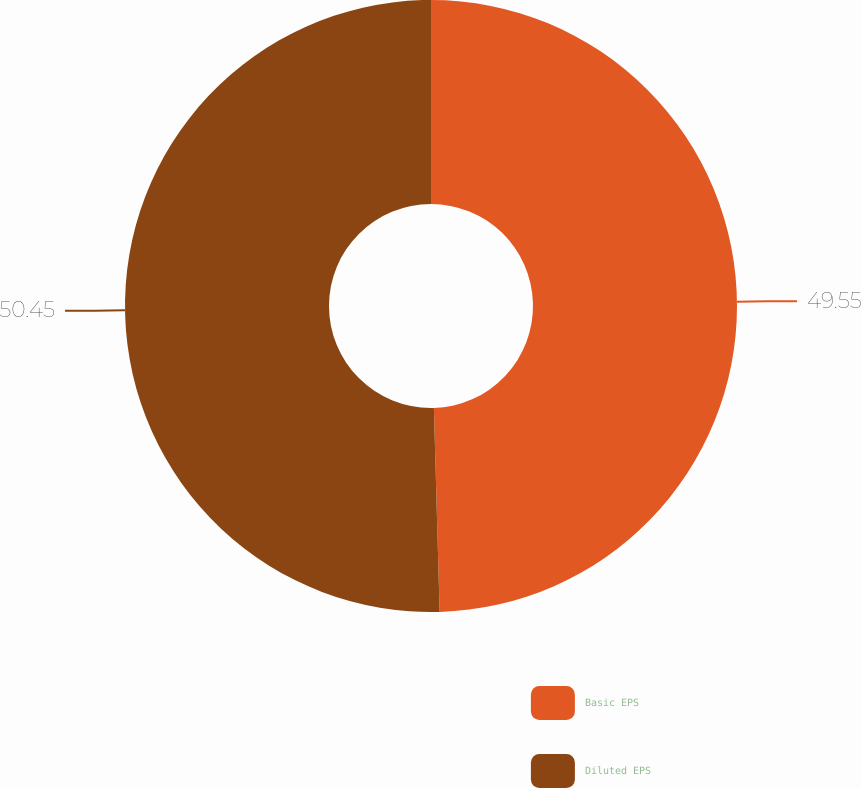Convert chart. <chart><loc_0><loc_0><loc_500><loc_500><pie_chart><fcel>Basic EPS<fcel>Diluted EPS<nl><fcel>49.55%<fcel>50.45%<nl></chart> 